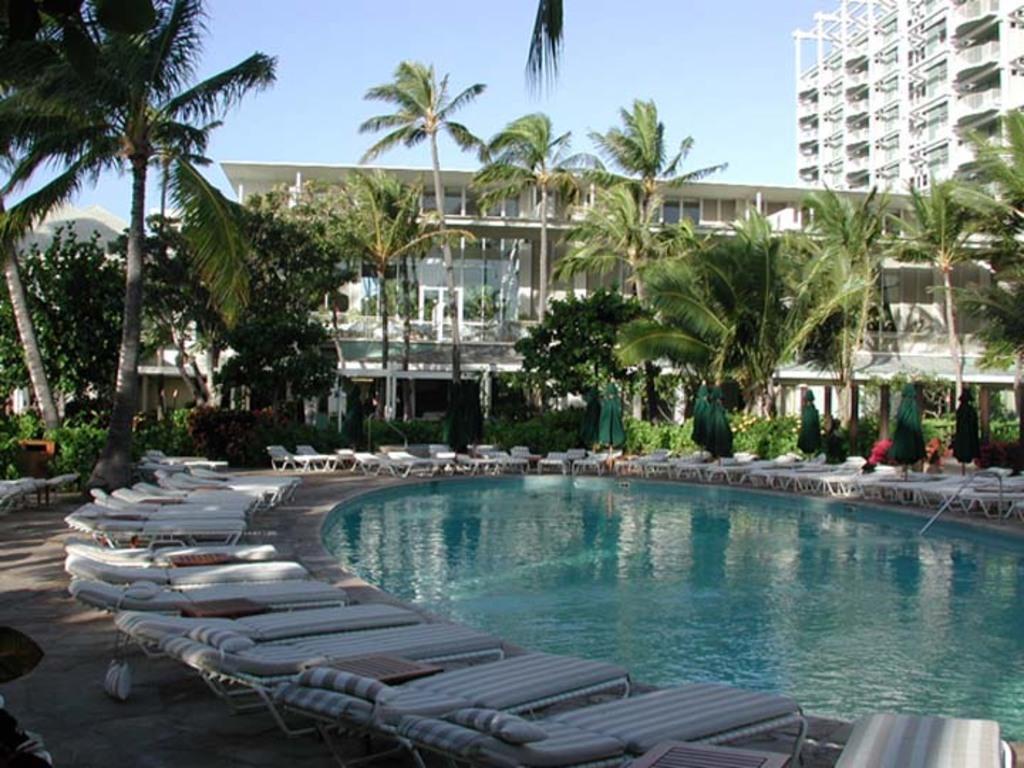In one or two sentences, can you explain what this image depicts? In this picture we can see water, beside the water we can see chairs on the ground, here we can see buildings, trees, plants and some objects and we can see sky in the background. 